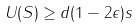Convert formula to latex. <formula><loc_0><loc_0><loc_500><loc_500>U ( S ) \geq d ( 1 - 2 \epsilon ) s</formula> 